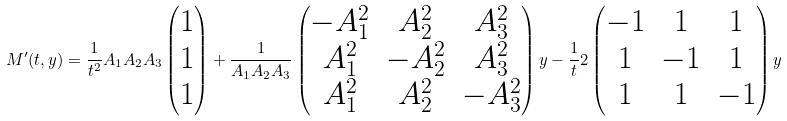Convert formula to latex. <formula><loc_0><loc_0><loc_500><loc_500>M ^ { \prime } ( t , y ) = \frac { 1 } { t ^ { 2 } } A _ { 1 } A _ { 2 } A _ { 3 } \begin{pmatrix} 1 \\ 1 \\ 1 \end{pmatrix} + \frac { 1 } { A _ { 1 } A _ { 2 } A _ { 3 } } \begin{pmatrix} - A _ { 1 } ^ { 2 } & A _ { 2 } ^ { 2 } & A _ { 3 } ^ { 2 } \\ A _ { 1 } ^ { 2 } & - A _ { 2 } ^ { 2 } & A _ { 3 } ^ { 2 } \\ A _ { 1 } ^ { 2 } & A _ { 2 } ^ { 2 } & - A _ { 3 } ^ { 2 } \end{pmatrix} y - \frac { 1 } { t } 2 \begin{pmatrix} - 1 & 1 & 1 \\ 1 & - 1 & 1 \\ 1 & 1 & - 1 \end{pmatrix} y</formula> 